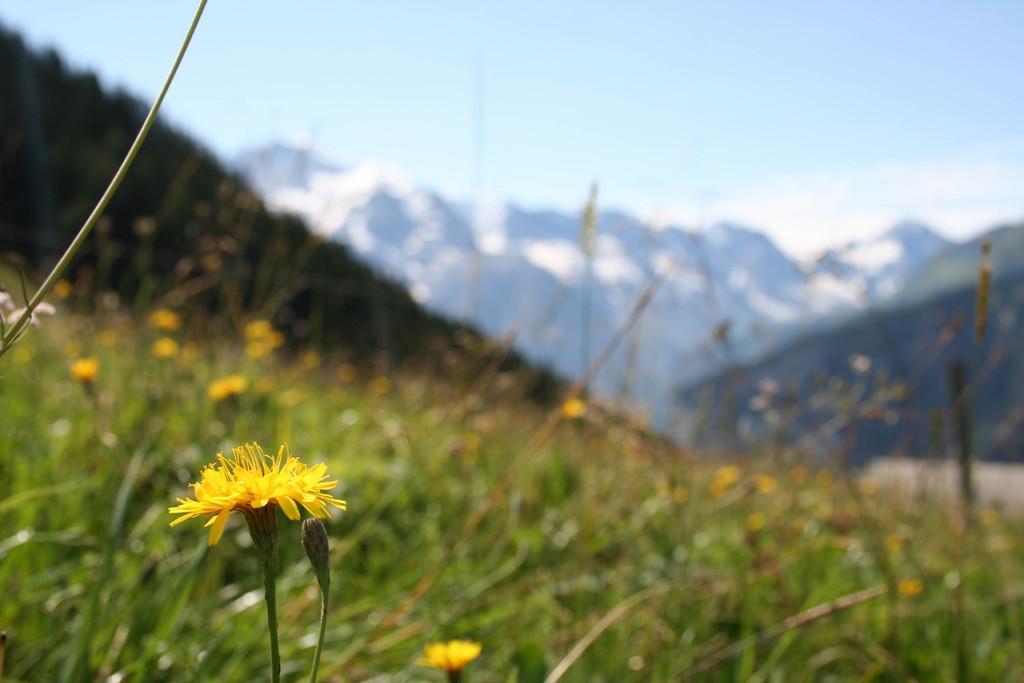In one or two sentences, can you explain what this image depicts? In this image we can see flowers, plants, hills, mountains and sky. 